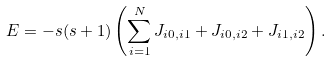Convert formula to latex. <formula><loc_0><loc_0><loc_500><loc_500>E = - s ( s + 1 ) \left ( \sum _ { i = 1 } ^ { N } J _ { i 0 , i 1 } + J _ { i 0 , i 2 } + J _ { i 1 , i 2 } \right ) .</formula> 